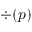<formula> <loc_0><loc_0><loc_500><loc_500>\div ( p \ u )</formula> 